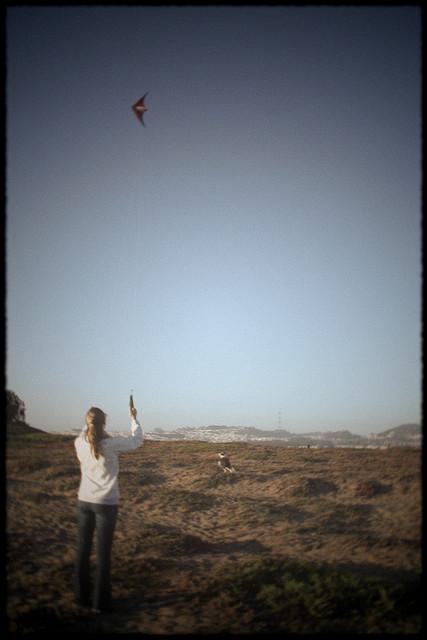Does this person have short hair?
Answer briefly. No. Are these people near water?
Concise answer only. No. Is this a funny picture?
Answer briefly. No. Is this person agile?
Keep it brief. Yes. Are they playing in a cage?
Short answer required. No. What the person wearing visor?
Keep it brief. No. Are there clouds visible?
Give a very brief answer. No. Is this in the middle of the day?
Be succinct. Yes. What is she playing?
Write a very short answer. Kite flying. How is the weather?
Write a very short answer. Clear. Is the woman waiting for someone?
Answer briefly. No. Are the kits flying over water?
Quick response, please. No. Is the woman being active?
Give a very brief answer. Yes. What color is the boy's hair?
Short answer required. Blonde. How many people are wearing white shirts?
Answer briefly. 1. What is the weather like in this picture?
Keep it brief. Sunny. What is the girl trying to do?
Short answer required. Fly kite. Is this a children's activity?
Give a very brief answer. Yes. What is the woman holding?
Concise answer only. Kite. Is it dark?
Answer briefly. No. What time is it?
Quick response, please. Daytime. Is there a red fire hydrant in this photo?
Answer briefly. No. What are they playing with?
Short answer required. Kite. What is in the air?
Answer briefly. Kite. What sport is the man playing?
Be succinct. Kite flying. What kind of landscape is pictured here?
Concise answer only. Hills. What is the man riding on?
Answer briefly. Nothing. What is the person doing?
Write a very short answer. Flying kite. What is not allowed?
Give a very brief answer. Littering. Is the person in the air?
Be succinct. No. Are there any buildings?
Keep it brief. No. Is it a rainy day?
Be succinct. No. Is this a man or woman?
Concise answer only. Woman. Could a bird poke a hole in the kite?
Be succinct. Yes. Which animal is live?
Be succinct. Human. What is floating overhead?
Give a very brief answer. Kite. Is this person performing a trick?
Keep it brief. No. Is this nighttime?
Quick response, please. No. Is there a body of water in this photo?
Write a very short answer. No. What is flying?
Be succinct. Kite. Is that person carrying a bag?
Be succinct. No. What is she holding?
Be succinct. Kite. Is this woman's feet on the ground?
Concise answer only. Yes. What kind of park is shown here?
Quick response, please. National park. Is that the ocean?
Quick response, please. No. How many people are standing over the dog?
Write a very short answer. 1. Are there any birds in the air?
Quick response, please. No. What sport is this?
Write a very short answer. Kite flying. Does this person appear to be skilled at what he is doing?
Keep it brief. Yes. What is causing the lights to be hazy in this picture?
Concise answer only. Filter. In what position are the woman's legs?
Answer briefly. Straight. How many kites are flying in the sky?
Be succinct. 1. Is there grass in the photo?
Write a very short answer. Yes. Is the kite an alien?
Write a very short answer. No. What is the woman doing?
Quick response, please. Flying kite. How many beds are pictured?
Keep it brief. 0. What color is the child's shirt?
Short answer required. White. Are there trees in the valley?
Give a very brief answer. No. 